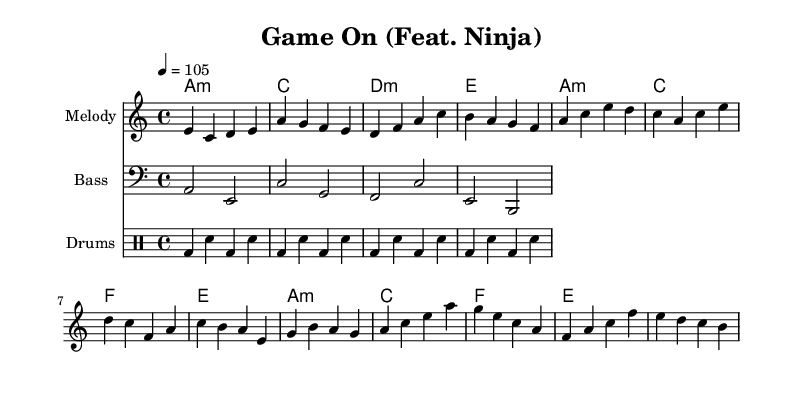What is the key signature of this music? The key signature shows A minor, indicated by one sharp, which can also suggest C major since it has the same notes.
Answer: A minor What is the time signature of this music? The time signature is specified as 4/4, which indicates four beats per measure and is a common time signature in many genres.
Answer: 4/4 What is the tempo marking of this piece? The tempo indication is set at 105 beats per minute, showing the speed of the music.
Answer: 105 How many measures are in the chorus? The chorus consists of four measures, indicated by the section categorized as the Chorus in the melody.
Answer: 4 What is the name of the featured artist in this piece? The header states "Feat. Ninja," clearly identifying Ninja as the featured artist in the collaboration title.
Answer: Ninja What is the chord structure in the verse? The chord structure repeats A minor, C major, F major, and E major for the verses, as indicated under harmonies.
Answer: A minor, C, F, E What genre combination does this music represent? The genre is a blend of Latin and hip-hop elements, reflecting both musical styles in the rhythmic patterns and instrumentation.
Answer: Latin hip-hop 